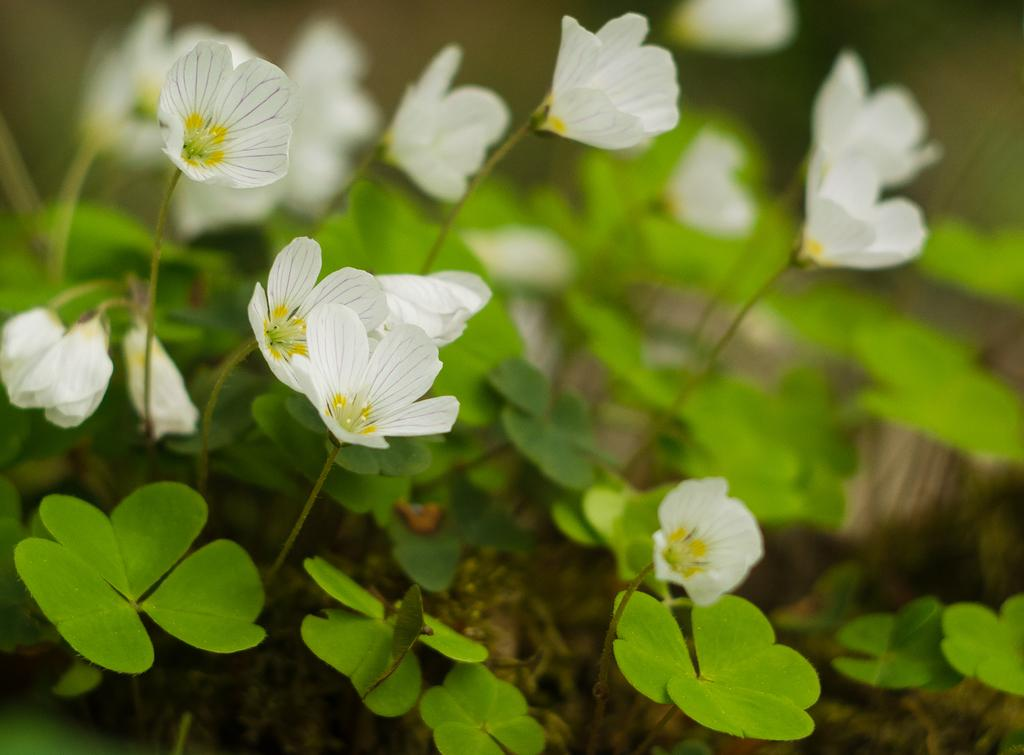What type of living organisms can be seen in the image? There are flowers and plants visible in the image. Can you describe the plants in the image? The plants in the image are not specified, but they are present alongside the flowers. What type of office furniture can be seen in the image? There is no office furniture present in the image; it features flowers and plants. What type of pest is visible on the leaves of the plants in the image? There is no pest visible on the leaves of the plants in the image; only flowers and plants are present. 